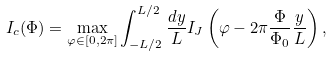Convert formula to latex. <formula><loc_0><loc_0><loc_500><loc_500>I _ { c } ( \Phi ) = \max _ { \varphi \in [ 0 , 2 \pi ] } \int _ { - L / 2 } ^ { L / 2 } \frac { d y } { L } I _ { J } \left ( \varphi - 2 \pi \frac { \Phi } { \Phi _ { 0 } } \frac { y } { L } \right ) ,</formula> 